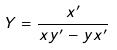Convert formula to latex. <formula><loc_0><loc_0><loc_500><loc_500>Y = \frac { x ^ { \prime } } { x y ^ { \prime } - y x ^ { \prime } }</formula> 